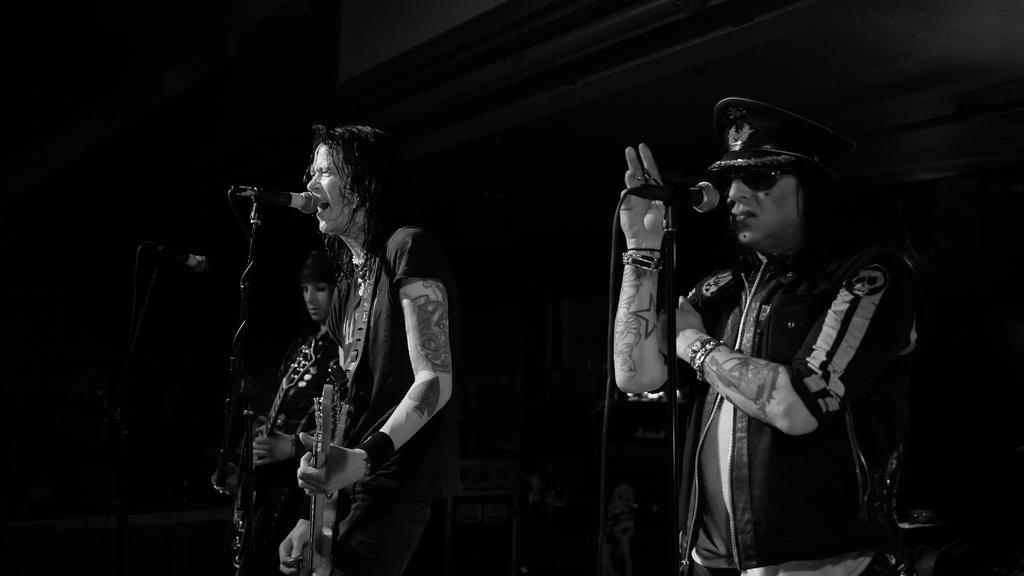In one or two sentences, can you explain what this image depicts? In this image i can see three persons standing and singing in front of a micro phone. 